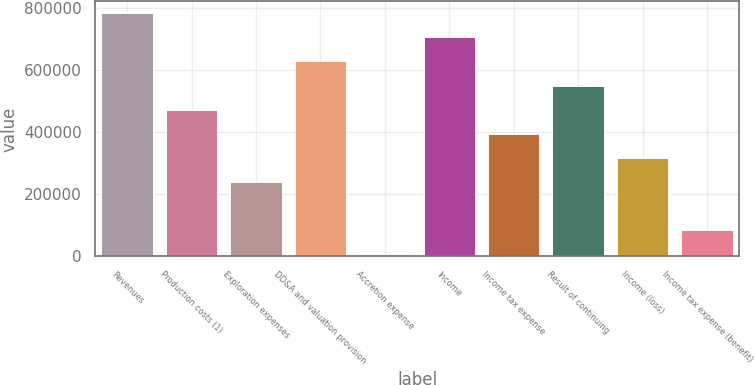Convert chart to OTSL. <chart><loc_0><loc_0><loc_500><loc_500><bar_chart><fcel>Revenues<fcel>Production costs (1)<fcel>Exploration expenses<fcel>DD&A and valuation provision<fcel>Accretion expense<fcel>Income<fcel>Income tax expense<fcel>Result of continuing<fcel>Income (loss)<fcel>Income tax expense (benefit)<nl><fcel>781766<fcel>472268<fcel>240144<fcel>627017<fcel>8021<fcel>704392<fcel>394894<fcel>549642<fcel>317519<fcel>85395.5<nl></chart> 